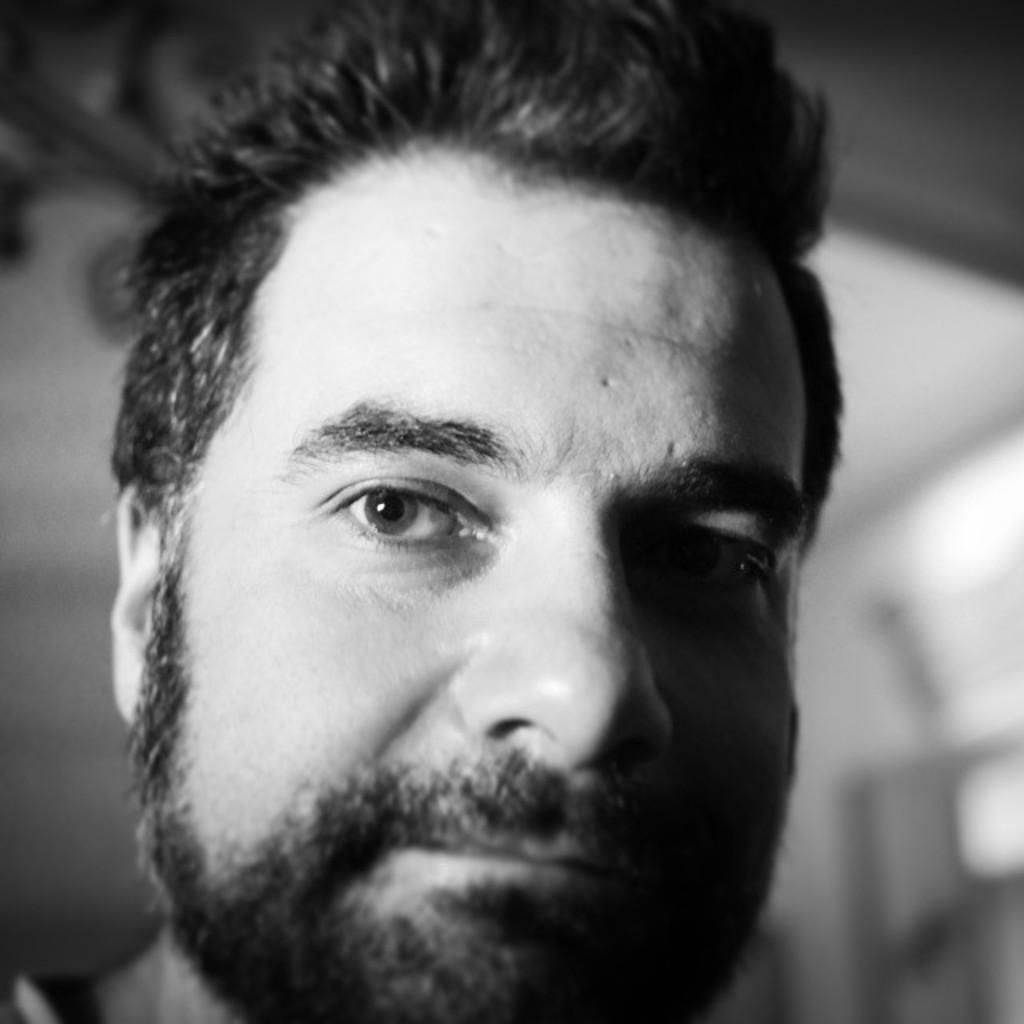What is the color scheme of the image? The image is black and white. Who is present in the image? There is a man in the image. What is the man doing in the image? The man is looking at a picture. Can you describe the background of the image? The background of the image is blurred. What is the man's opinion about the error in the image? There is no mention of an error in the image, and the man's opinion cannot be determined from the image alone. 